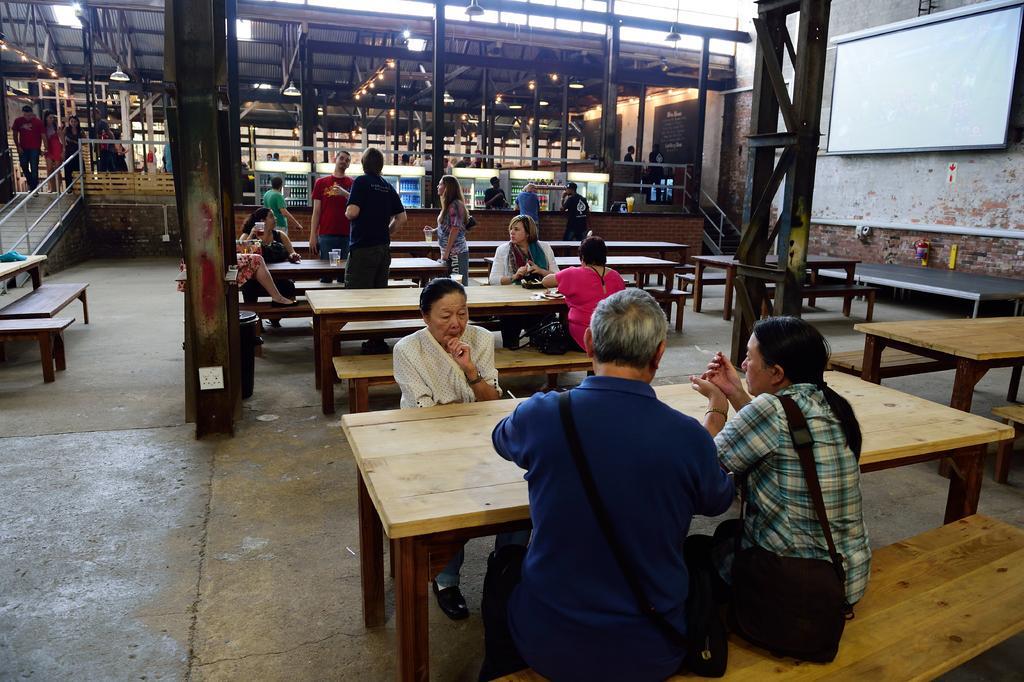Please provide a concise description of this image. In this image I can see few person sitting on the bench. There is a table and few person are walking on the floor. On the right side there is a screen. 